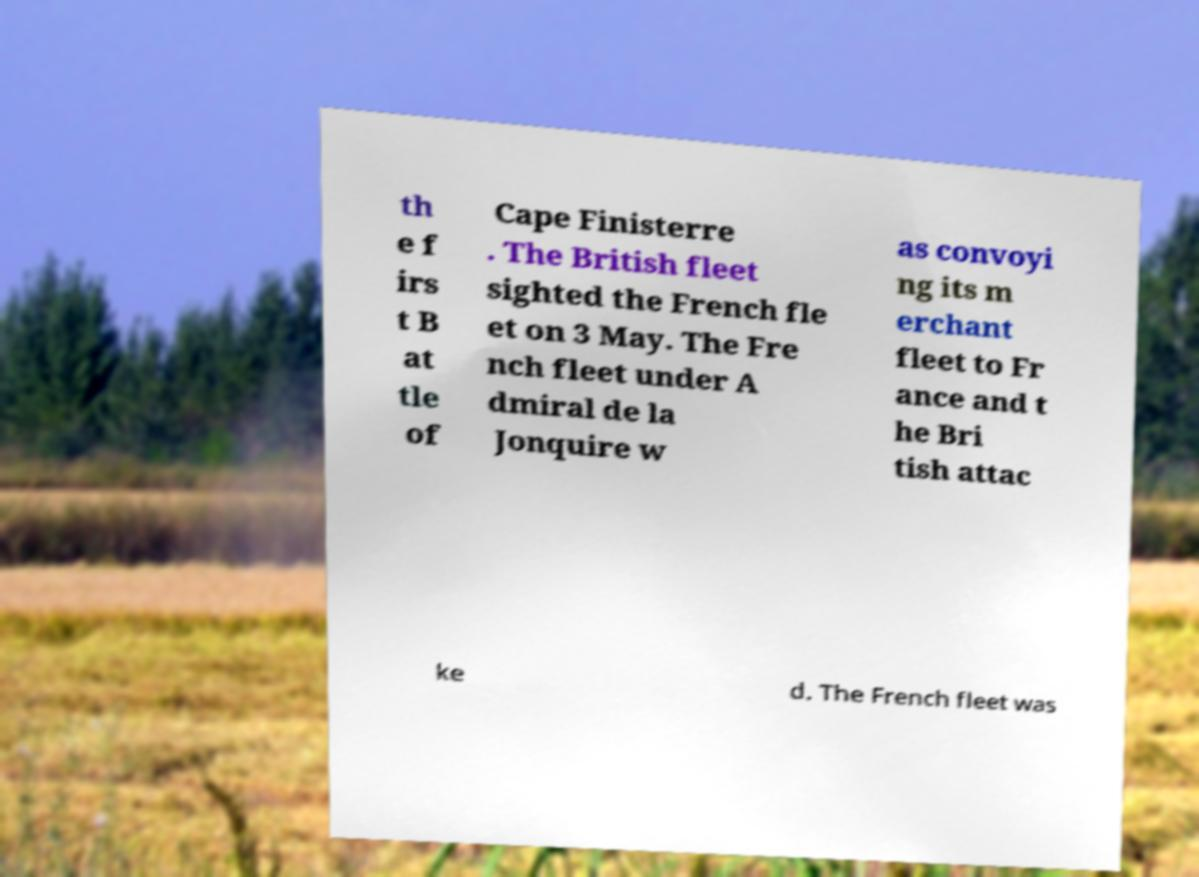There's text embedded in this image that I need extracted. Can you transcribe it verbatim? th e f irs t B at tle of Cape Finisterre . The British fleet sighted the French fle et on 3 May. The Fre nch fleet under A dmiral de la Jonquire w as convoyi ng its m erchant fleet to Fr ance and t he Bri tish attac ke d. The French fleet was 